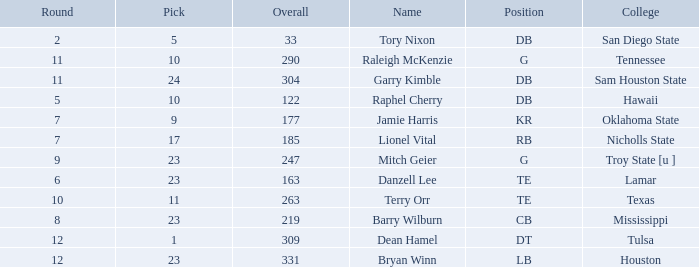Which Overall is the highest one that has a Name of raleigh mckenzie, and a Pick larger than 10? None. 